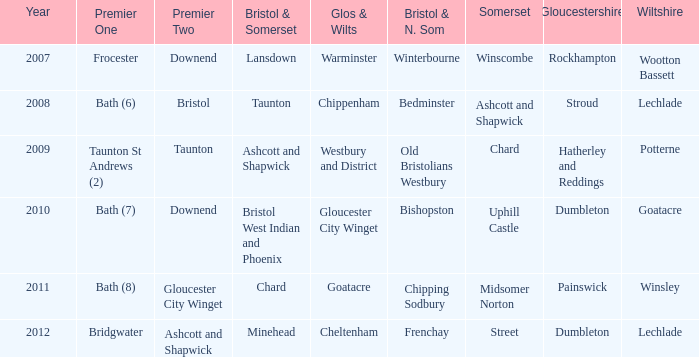What is the glos & wilts where the bristol & somerset is lansdown? Warminster. Could you parse the entire table? {'header': ['Year', 'Premier One', 'Premier Two', 'Bristol & Somerset', 'Glos & Wilts', 'Bristol & N. Som', 'Somerset', 'Gloucestershire', 'Wiltshire'], 'rows': [['2007', 'Frocester', 'Downend', 'Lansdown', 'Warminster', 'Winterbourne', 'Winscombe', 'Rockhampton', 'Wootton Bassett'], ['2008', 'Bath (6)', 'Bristol', 'Taunton', 'Chippenham', 'Bedminster', 'Ashcott and Shapwick', 'Stroud', 'Lechlade'], ['2009', 'Taunton St Andrews (2)', 'Taunton', 'Ashcott and Shapwick', 'Westbury and District', 'Old Bristolians Westbury', 'Chard', 'Hatherley and Reddings', 'Potterne'], ['2010', 'Bath (7)', 'Downend', 'Bristol West Indian and Phoenix', 'Gloucester City Winget', 'Bishopston', 'Uphill Castle', 'Dumbleton', 'Goatacre'], ['2011', 'Bath (8)', 'Gloucester City Winget', 'Chard', 'Goatacre', 'Chipping Sodbury', 'Midsomer Norton', 'Painswick', 'Winsley'], ['2012', 'Bridgwater', 'Ashcott and Shapwick', 'Minehead', 'Cheltenham', 'Frenchay', 'Street', 'Dumbleton', 'Lechlade']]} 